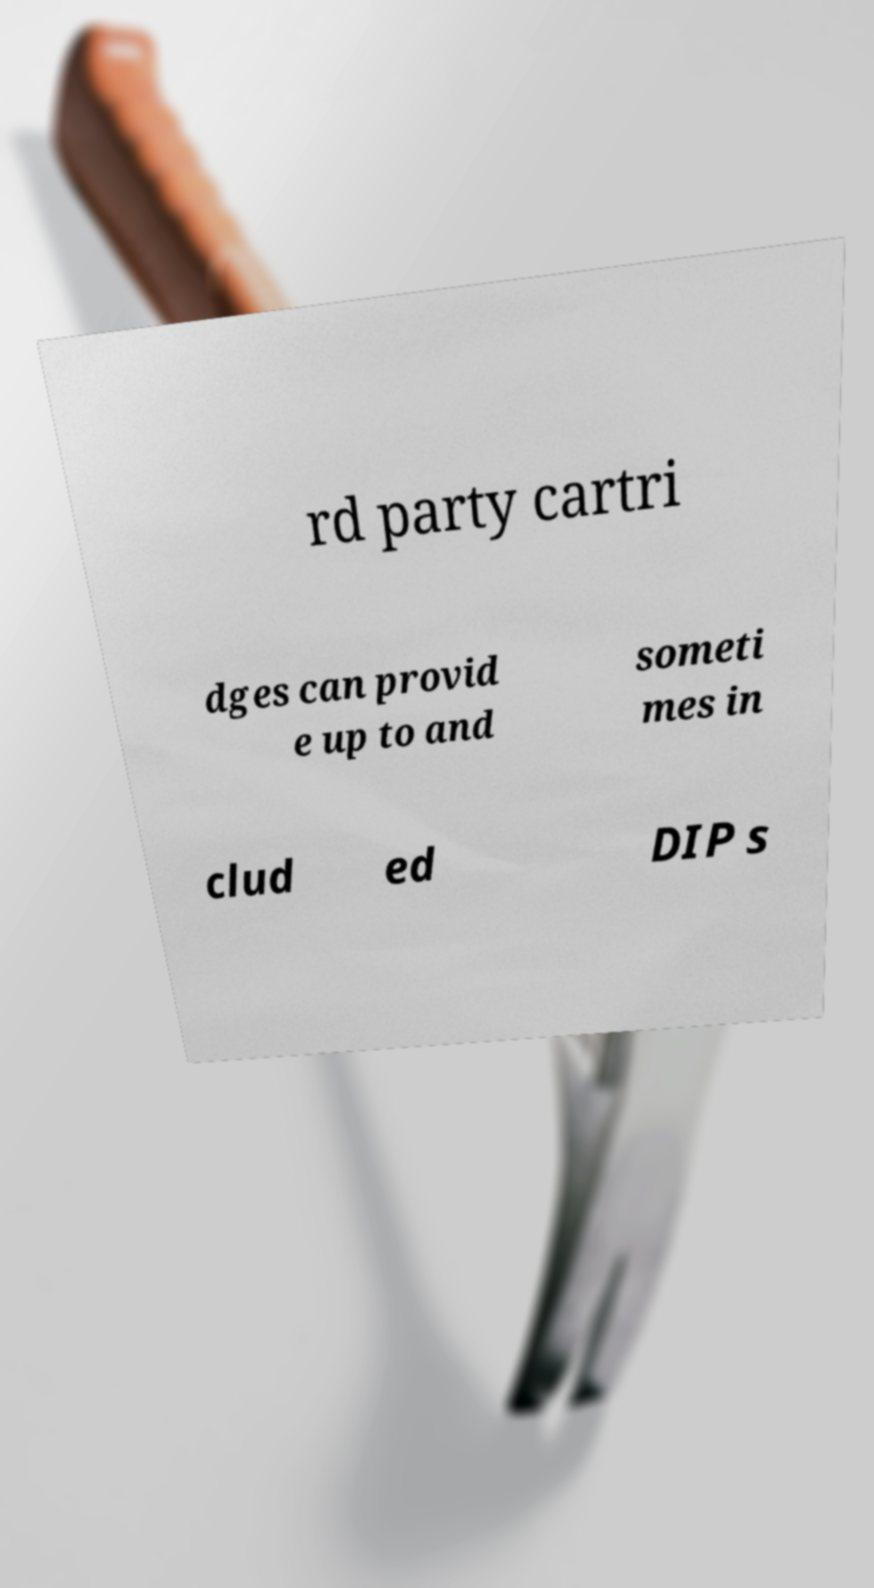Please read and relay the text visible in this image. What does it say? rd party cartri dges can provid e up to and someti mes in clud ed DIP s 